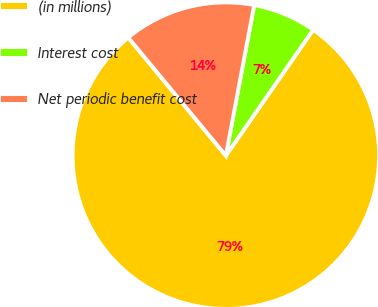<chart> <loc_0><loc_0><loc_500><loc_500><pie_chart><fcel>(in millions)<fcel>Interest cost<fcel>Net periodic benefit cost<nl><fcel>79.36%<fcel>6.69%<fcel>13.95%<nl></chart> 